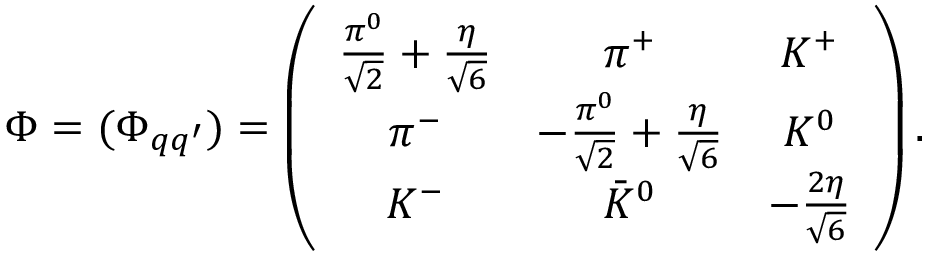Convert formula to latex. <formula><loc_0><loc_0><loc_500><loc_500>\Phi = ( { \Phi _ { q q ^ { \prime } } } ) = \left ( \begin{array} { c c c } { { \frac { \pi ^ { 0 } } { \sqrt { 2 } } + \frac { \eta } { \sqrt { 6 } } } } & { { \pi ^ { + } } } & { { K ^ { + } } } \\ { { \pi ^ { - } } } & { { - \frac { \pi ^ { 0 } } { \sqrt { 2 } } + \frac { \eta } { \sqrt { 6 } } } } & { { K ^ { 0 } } } \\ { { K ^ { - } } } & { { \bar { K } ^ { 0 } } } & { { - \frac { 2 \eta } { \sqrt { 6 } } } } \end{array} \right ) .</formula> 